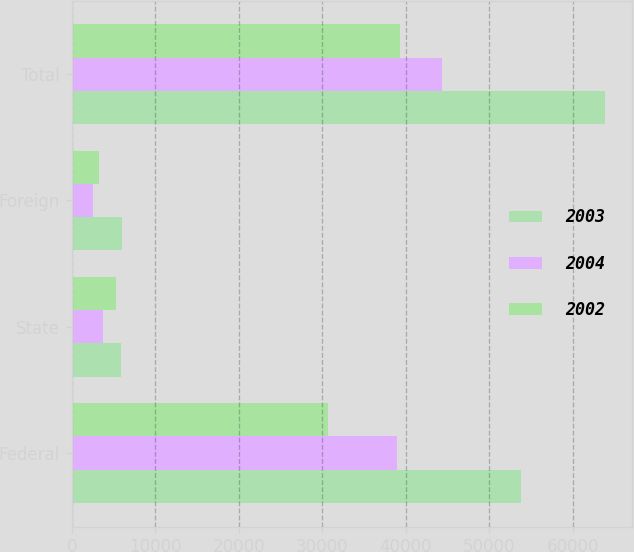Convert chart to OTSL. <chart><loc_0><loc_0><loc_500><loc_500><stacked_bar_chart><ecel><fcel>Federal<fcel>State<fcel>Foreign<fcel>Total<nl><fcel>2003<fcel>53810<fcel>5874<fcel>6023<fcel>63905<nl><fcel>2004<fcel>38954<fcel>3723<fcel>2561<fcel>44296<nl><fcel>2002<fcel>30660<fcel>5247<fcel>3254<fcel>39288<nl></chart> 